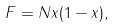Convert formula to latex. <formula><loc_0><loc_0><loc_500><loc_500>F = N x ( 1 - x ) ,</formula> 